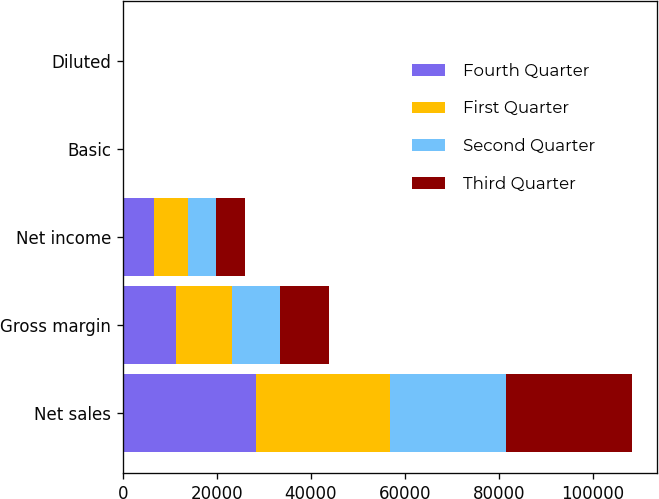Convert chart. <chart><loc_0><loc_0><loc_500><loc_500><stacked_bar_chart><ecel><fcel>Net sales<fcel>Gross margin<fcel>Net income<fcel>Basic<fcel>Diluted<nl><fcel>Fourth Quarter<fcel>28270<fcel>11380<fcel>6623<fcel>7.13<fcel>7.05<nl><fcel>First Quarter<fcel>28571<fcel>11922<fcel>7308<fcel>7.89<fcel>7.79<nl><fcel>Second Quarter<fcel>24667<fcel>10218<fcel>5987<fcel>6.49<fcel>6.4<nl><fcel>Third Quarter<fcel>26741<fcel>10298<fcel>6004<fcel>6.53<fcel>6.43<nl></chart> 